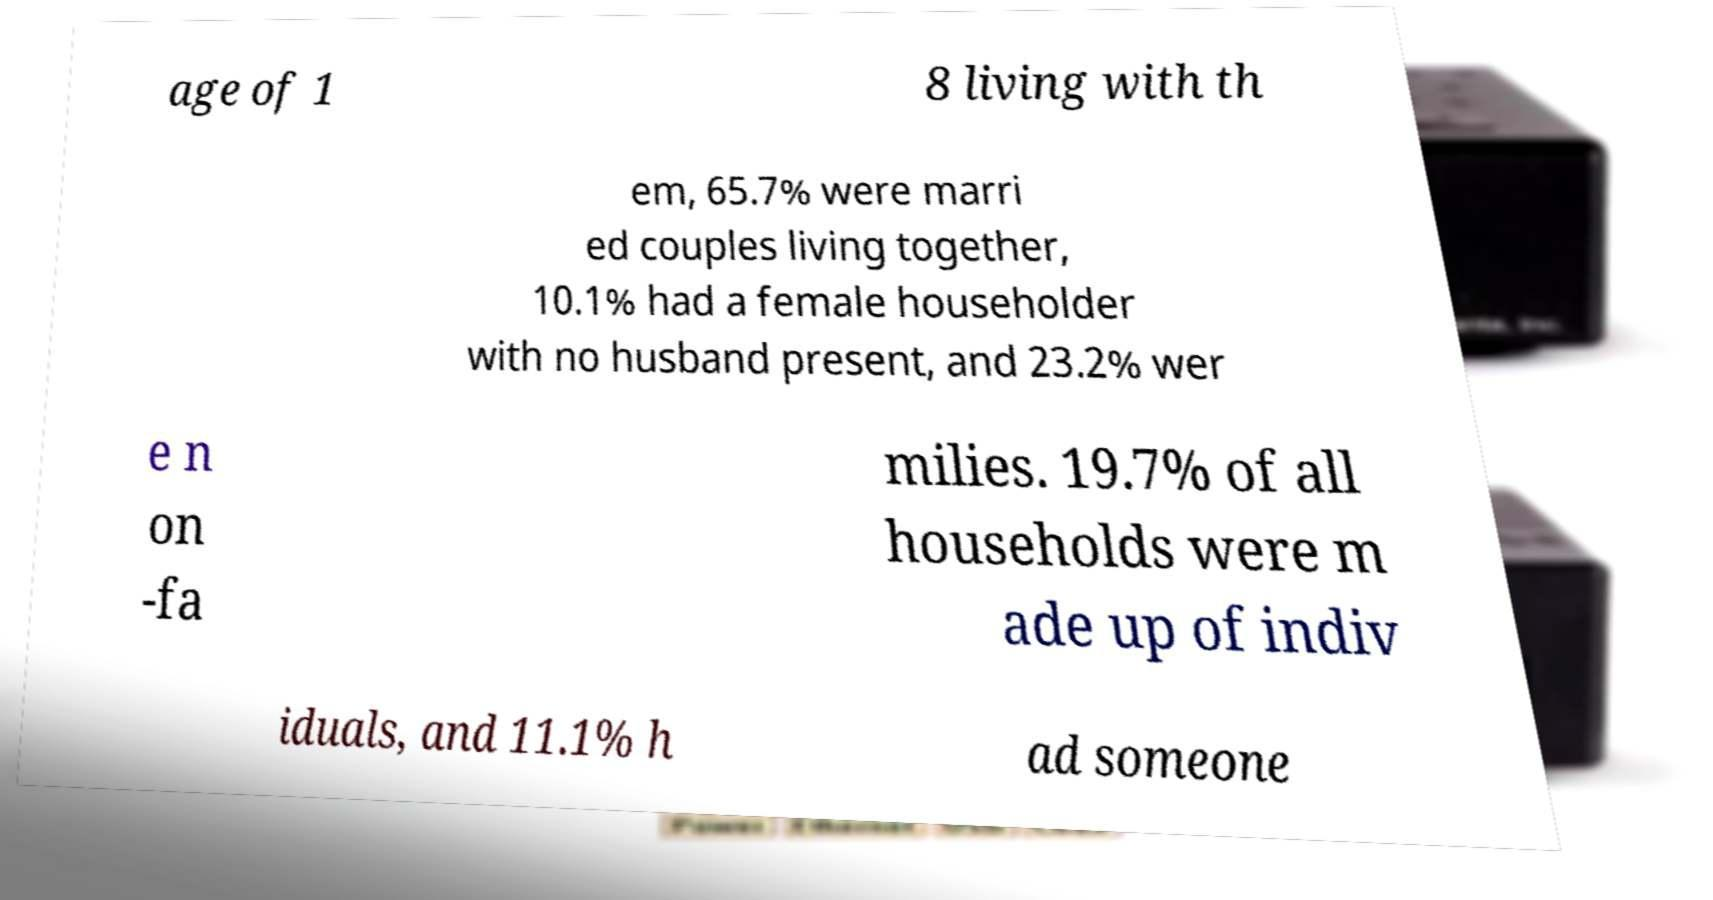Please read and relay the text visible in this image. What does it say? age of 1 8 living with th em, 65.7% were marri ed couples living together, 10.1% had a female householder with no husband present, and 23.2% wer e n on -fa milies. 19.7% of all households were m ade up of indiv iduals, and 11.1% h ad someone 